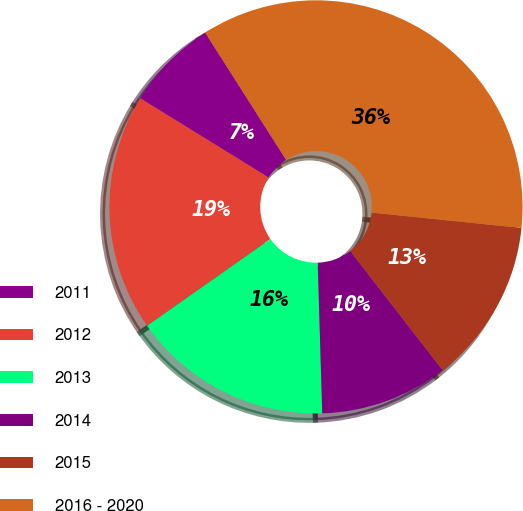Convert chart to OTSL. <chart><loc_0><loc_0><loc_500><loc_500><pie_chart><fcel>2011<fcel>2012<fcel>2013<fcel>2014<fcel>2015<fcel>2016 - 2020<nl><fcel>7.18%<fcel>18.56%<fcel>15.72%<fcel>10.02%<fcel>12.87%<fcel>35.64%<nl></chart> 